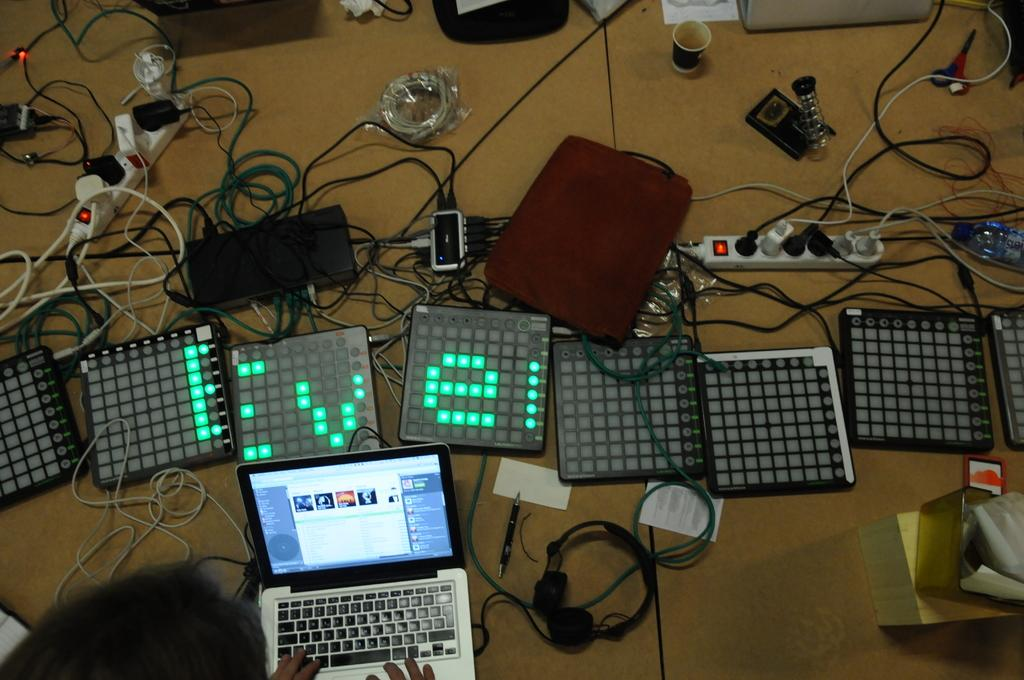<image>
Present a compact description of the photo's key features. A computer with several lit panels one of which has an e on it. 